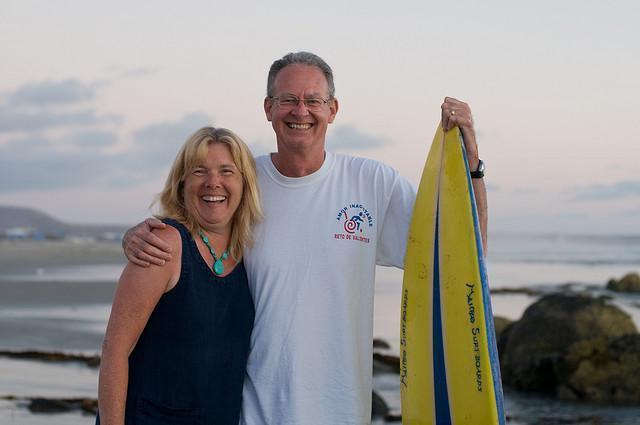How many girls are there?
Give a very brief answer. 1. How many surfboards are in this picture?
Give a very brief answer. 1. How many people are in the photo?
Give a very brief answer. 2. 